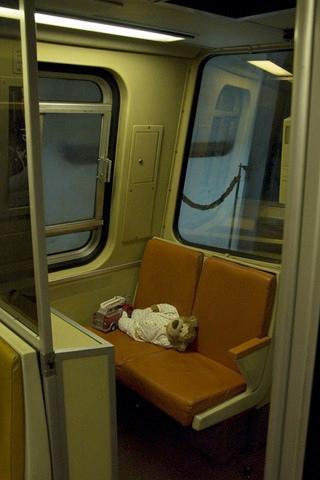How many stuffed animals are in this picture?
Give a very brief answer. 1. 